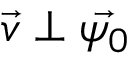Convert formula to latex. <formula><loc_0><loc_0><loc_500><loc_500>\vec { v } \perp \vec { \psi _ { 0 } }</formula> 